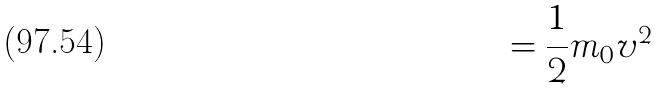Convert formula to latex. <formula><loc_0><loc_0><loc_500><loc_500>= \frac { 1 } { 2 } m _ { 0 } v ^ { 2 }</formula> 